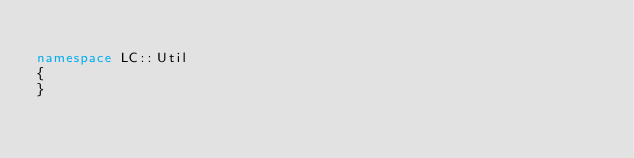<code> <loc_0><loc_0><loc_500><loc_500><_C++_>
namespace LC::Util
{
}
</code> 